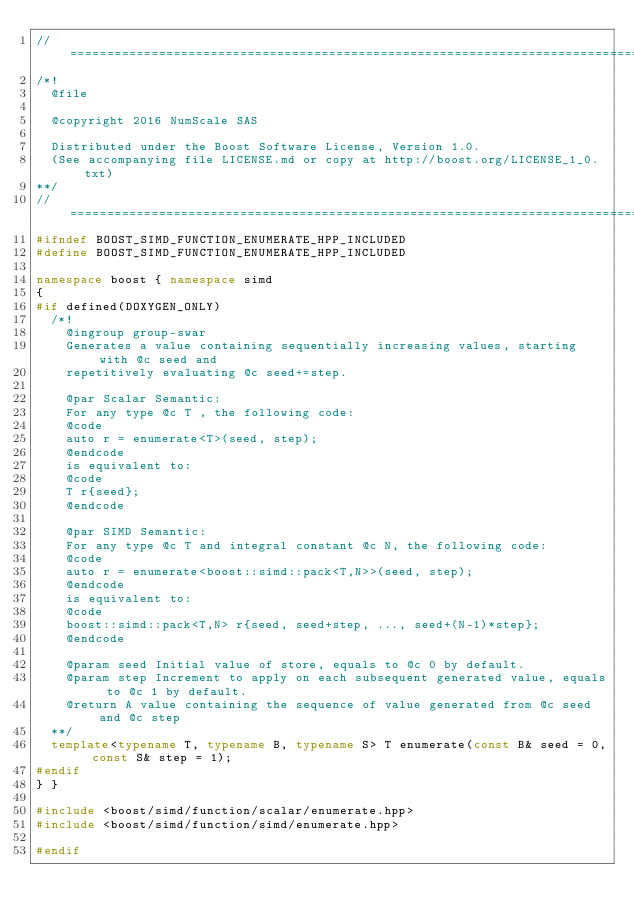<code> <loc_0><loc_0><loc_500><loc_500><_C++_>//==================================================================================================
/*!
  @file

  @copyright 2016 NumScale SAS

  Distributed under the Boost Software License, Version 1.0.
  (See accompanying file LICENSE.md or copy at http://boost.org/LICENSE_1_0.txt)
**/
//==================================================================================================
#ifndef BOOST_SIMD_FUNCTION_ENUMERATE_HPP_INCLUDED
#define BOOST_SIMD_FUNCTION_ENUMERATE_HPP_INCLUDED

namespace boost { namespace simd
{
#if defined(DOXYGEN_ONLY)
  /*!
    @ingroup group-swar
    Generates a value containing sequentially increasing values, starting with @c seed and
    repetitively evaluating @c seed+=step.

    @par Scalar Semantic:
    For any type @c T , the following code:
    @code
    auto r = enumerate<T>(seed, step);
    @endcode
    is equivalent to:
    @code
    T r{seed};
    @endcode

    @par SIMD Semantic:
    For any type @c T and integral constant @c N, the following code:
    @code
    auto r = enumerate<boost::simd::pack<T,N>>(seed, step);
    @endcode
    is equivalent to:
    @code
    boost::simd::pack<T,N> r{seed, seed+step, ..., seed+(N-1)*step};
    @endcode

    @param seed Initial value of store, equals to @c 0 by default.
    @param step Increment to apply on each subsequent generated value, equals to @c 1 by default.
    @return A value containing the sequence of value generated from @c seed and @c step
  **/
  template<typename T, typename B, typename S> T enumerate(const B& seed = 0, const S& step = 1);
#endif
} }

#include <boost/simd/function/scalar/enumerate.hpp>
#include <boost/simd/function/simd/enumerate.hpp>

#endif
</code> 